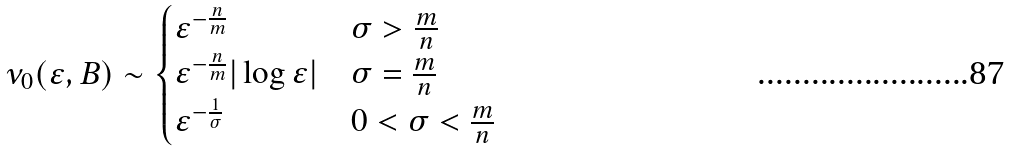Convert formula to latex. <formula><loc_0><loc_0><loc_500><loc_500>\nu _ { 0 } ( \varepsilon , B ) \sim \begin{cases} \varepsilon ^ { - \frac { n } { m } } & \sigma > \frac { m } { n } \\ \varepsilon ^ { - \frac { n } { m } } | \log \varepsilon | & \sigma = \frac { m } { n } \\ \varepsilon ^ { - \frac { 1 } { \sigma } } & 0 < \sigma < \frac { m } { n } \end{cases}</formula> 